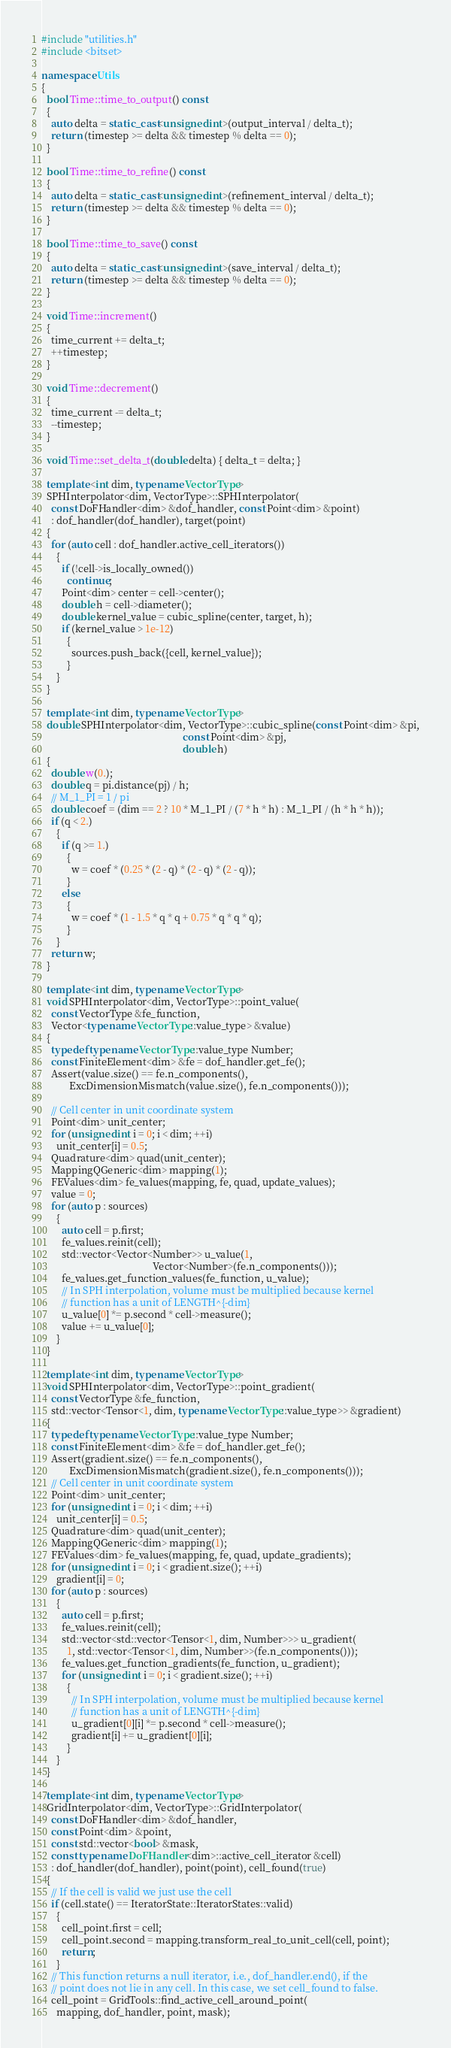<code> <loc_0><loc_0><loc_500><loc_500><_C++_>#include "utilities.h"
#include <bitset>

namespace Utils
{
  bool Time::time_to_output() const
  {
    auto delta = static_cast<unsigned int>(output_interval / delta_t);
    return (timestep >= delta && timestep % delta == 0);
  }

  bool Time::time_to_refine() const
  {
    auto delta = static_cast<unsigned int>(refinement_interval / delta_t);
    return (timestep >= delta && timestep % delta == 0);
  }

  bool Time::time_to_save() const
  {
    auto delta = static_cast<unsigned int>(save_interval / delta_t);
    return (timestep >= delta && timestep % delta == 0);
  }

  void Time::increment()
  {
    time_current += delta_t;
    ++timestep;
  }

  void Time::decrement()
  {
    time_current -= delta_t;
    --timestep;
  }

  void Time::set_delta_t(double delta) { delta_t = delta; }

  template <int dim, typename VectorType>
  SPHInterpolator<dim, VectorType>::SPHInterpolator(
    const DoFHandler<dim> &dof_handler, const Point<dim> &point)
    : dof_handler(dof_handler), target(point)
  {
    for (auto cell : dof_handler.active_cell_iterators())
      {
        if (!cell->is_locally_owned())
          continue;
        Point<dim> center = cell->center();
        double h = cell->diameter();
        double kernel_value = cubic_spline(center, target, h);
        if (kernel_value > 1e-12)
          {
            sources.push_back({cell, kernel_value});
          }
      }
  }

  template <int dim, typename VectorType>
  double SPHInterpolator<dim, VectorType>::cubic_spline(const Point<dim> &pi,
                                                        const Point<dim> &pj,
                                                        double h)
  {
    double w(0.);
    double q = pi.distance(pj) / h;
    // M_1_PI = 1 / pi
    double coef = (dim == 2 ? 10 * M_1_PI / (7 * h * h) : M_1_PI / (h * h * h));
    if (q < 2.)
      {
        if (q >= 1.)
          {
            w = coef * (0.25 * (2 - q) * (2 - q) * (2 - q));
          }
        else
          {
            w = coef * (1 - 1.5 * q * q + 0.75 * q * q * q);
          }
      }
    return w;
  }

  template <int dim, typename VectorType>
  void SPHInterpolator<dim, VectorType>::point_value(
    const VectorType &fe_function,
    Vector<typename VectorType::value_type> &value)
  {
    typedef typename VectorType::value_type Number;
    const FiniteElement<dim> &fe = dof_handler.get_fe();
    Assert(value.size() == fe.n_components(),
           ExcDimensionMismatch(value.size(), fe.n_components()));

    // Cell center in unit coordinate system
    Point<dim> unit_center;
    for (unsigned int i = 0; i < dim; ++i)
      unit_center[i] = 0.5;
    Quadrature<dim> quad(unit_center);
    MappingQGeneric<dim> mapping(1);
    FEValues<dim> fe_values(mapping, fe, quad, update_values);
    value = 0;
    for (auto p : sources)
      {
        auto cell = p.first;
        fe_values.reinit(cell);
        std::vector<Vector<Number>> u_value(1,
                                            Vector<Number>(fe.n_components()));
        fe_values.get_function_values(fe_function, u_value);
        // In SPH interpolation, volume must be multiplied because kernel
        // function has a unit of LENGTH^{-dim}
        u_value[0] *= p.second * cell->measure();
        value += u_value[0];
      }
  }

  template <int dim, typename VectorType>
  void SPHInterpolator<dim, VectorType>::point_gradient(
    const VectorType &fe_function,
    std::vector<Tensor<1, dim, typename VectorType::value_type>> &gradient)
  {
    typedef typename VectorType::value_type Number;
    const FiniteElement<dim> &fe = dof_handler.get_fe();
    Assert(gradient.size() == fe.n_components(),
           ExcDimensionMismatch(gradient.size(), fe.n_components()));
    // Cell center in unit coordinate system
    Point<dim> unit_center;
    for (unsigned int i = 0; i < dim; ++i)
      unit_center[i] = 0.5;
    Quadrature<dim> quad(unit_center);
    MappingQGeneric<dim> mapping(1);
    FEValues<dim> fe_values(mapping, fe, quad, update_gradients);
    for (unsigned int i = 0; i < gradient.size(); ++i)
      gradient[i] = 0;
    for (auto p : sources)
      {
        auto cell = p.first;
        fe_values.reinit(cell);
        std::vector<std::vector<Tensor<1, dim, Number>>> u_gradient(
          1, std::vector<Tensor<1, dim, Number>>(fe.n_components()));
        fe_values.get_function_gradients(fe_function, u_gradient);
        for (unsigned int i = 0; i < gradient.size(); ++i)
          {
            // In SPH interpolation, volume must be multiplied because kernel
            // function has a unit of LENGTH^{-dim}
            u_gradient[0][i] *= p.second * cell->measure();
            gradient[i] += u_gradient[0][i];
          }
      }
  }

  template <int dim, typename VectorType>
  GridInterpolator<dim, VectorType>::GridInterpolator(
    const DoFHandler<dim> &dof_handler,
    const Point<dim> &point,
    const std::vector<bool> &mask,
    const typename DoFHandler<dim>::active_cell_iterator &cell)
    : dof_handler(dof_handler), point(point), cell_found(true)
  {
    // If the cell is valid we just use the cell
    if (cell.state() == IteratorState::IteratorStates::valid)
      {
        cell_point.first = cell;
        cell_point.second = mapping.transform_real_to_unit_cell(cell, point);
        return;
      }
    // This function returns a null iterator, i.e., dof_handler.end(), if the
    // point does not lie in any cell. In this case, we set cell_found to false.
    cell_point = GridTools::find_active_cell_around_point(
      mapping, dof_handler, point, mask);</code> 